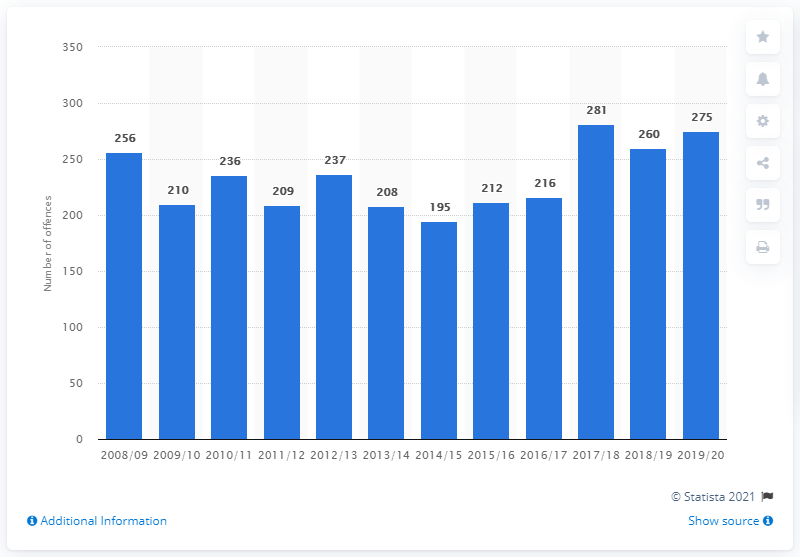Outline some significant characteristics in this image. In the previous reporting year, there were 260 knife homicides in England and Wales. There were 275 cases of knife homicides in England and Wales in the 2019/2020 fiscal year. 